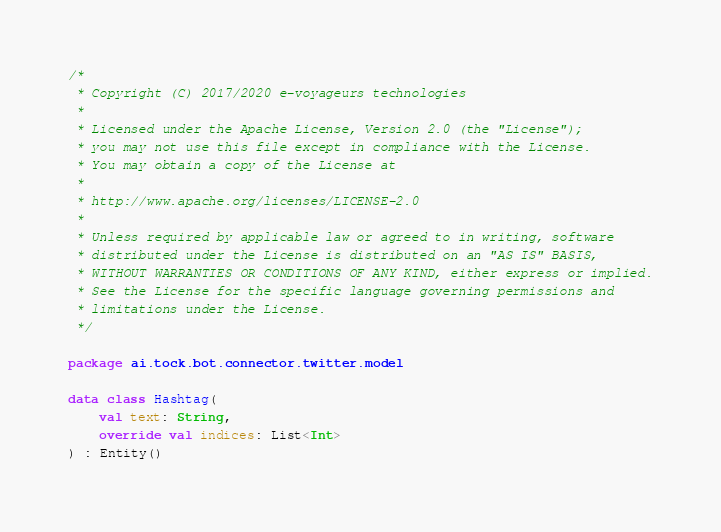Convert code to text. <code><loc_0><loc_0><loc_500><loc_500><_Kotlin_>/*
 * Copyright (C) 2017/2020 e-voyageurs technologies
 *
 * Licensed under the Apache License, Version 2.0 (the "License");
 * you may not use this file except in compliance with the License.
 * You may obtain a copy of the License at
 *
 * http://www.apache.org/licenses/LICENSE-2.0
 *
 * Unless required by applicable law or agreed to in writing, software
 * distributed under the License is distributed on an "AS IS" BASIS,
 * WITHOUT WARRANTIES OR CONDITIONS OF ANY KIND, either express or implied.
 * See the License for the specific language governing permissions and
 * limitations under the License.
 */

package ai.tock.bot.connector.twitter.model

data class Hashtag(
    val text: String,
    override val indices: List<Int>
) : Entity()</code> 